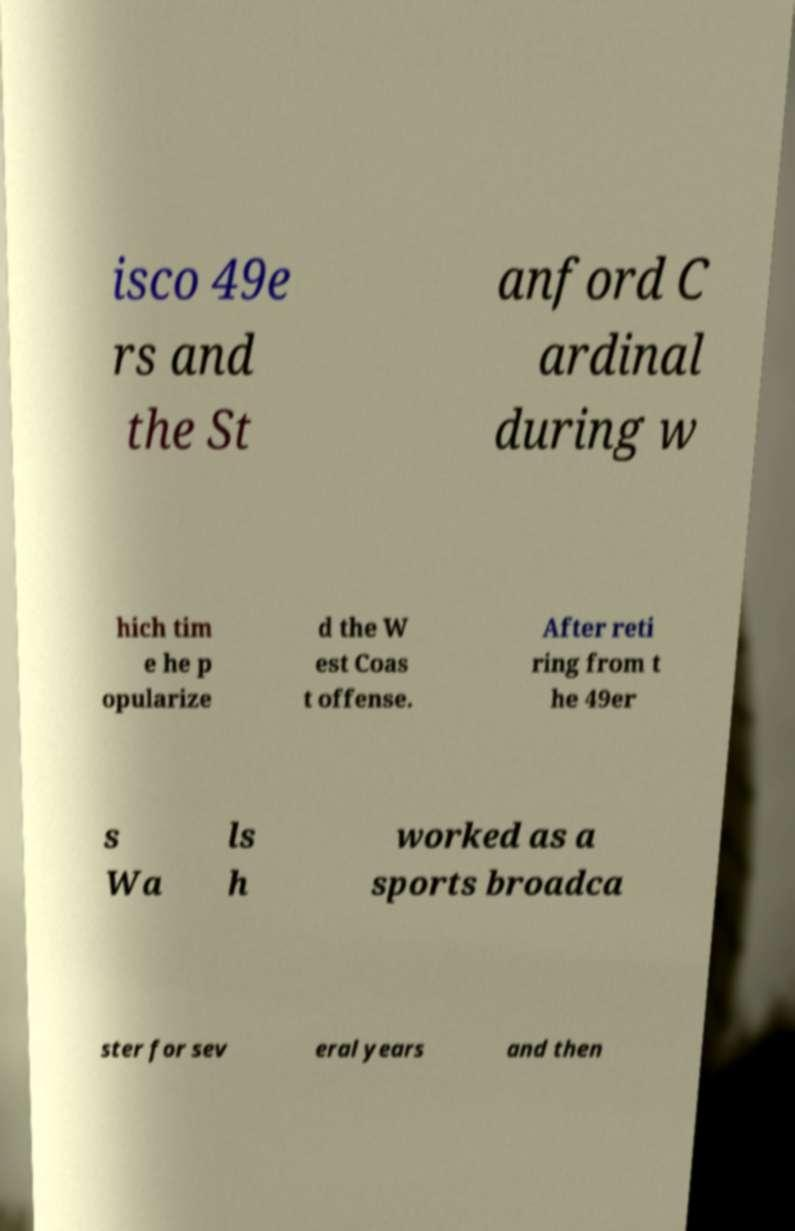There's text embedded in this image that I need extracted. Can you transcribe it verbatim? isco 49e rs and the St anford C ardinal during w hich tim e he p opularize d the W est Coas t offense. After reti ring from t he 49er s Wa ls h worked as a sports broadca ster for sev eral years and then 